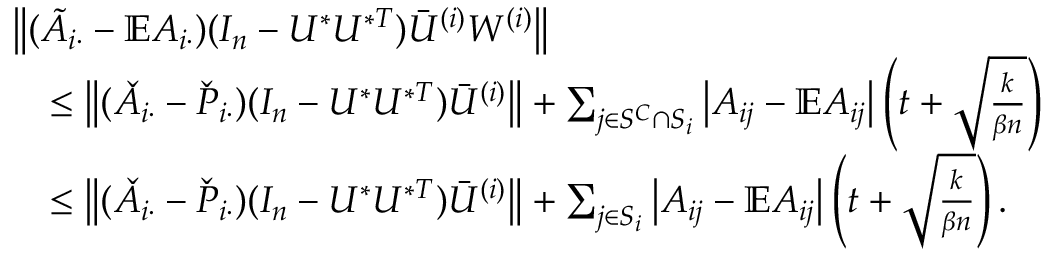<formula> <loc_0><loc_0><loc_500><loc_500>\begin{array} { r l } & { \left \| { ( \tilde { A } _ { i \cdot } - \mathbb { E } A _ { i \cdot } ) ( I _ { n } - U ^ { * } U ^ { * T } ) \bar { U } ^ { ( i ) } W ^ { ( i ) } } \right \| } \\ & { \quad \leq \left \| { ( \check { A } _ { i \cdot } - \check { P } _ { i \cdot } ) ( I _ { n } - U ^ { * } U ^ { * T } ) \bar { U } ^ { ( i ) } } \right \| + \sum _ { j \in S ^ { C } \cap S _ { i } } \left | A _ { i j } - \mathbb { E } A _ { i j } \right | \left ( t + \sqrt { \frac { k } { \beta n } } \right ) } \\ & { \quad \leq \left \| { ( \check { A } _ { i \cdot } - \check { P } _ { i \cdot } ) ( I _ { n } - U ^ { * } U ^ { * T } ) \bar { U } ^ { ( i ) } } \right \| + \sum _ { j \in S _ { i } } \left | A _ { i j } - \mathbb { E } A _ { i j } \right | \left ( t + \sqrt { \frac { k } { \beta n } } \right ) . } \end{array}</formula> 